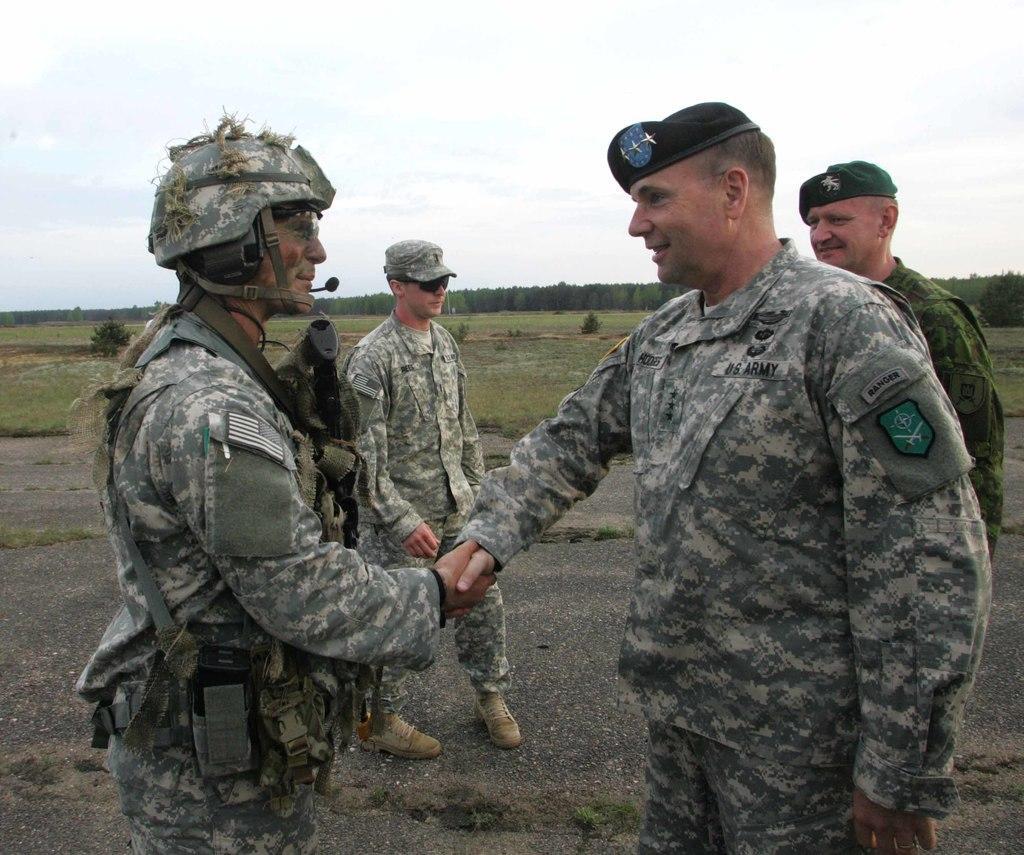Describe this image in one or two sentences. In this picture there are soldiers in the center of the image and there are trees in the background area of the image. 